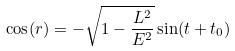<formula> <loc_0><loc_0><loc_500><loc_500>\cos ( r ) = - \sqrt { 1 - \frac { L ^ { 2 } } { E ^ { 2 } } } \sin ( t + t _ { 0 } )</formula> 